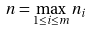Convert formula to latex. <formula><loc_0><loc_0><loc_500><loc_500>n = \max _ { 1 \leq i \leq m } n _ { i }</formula> 